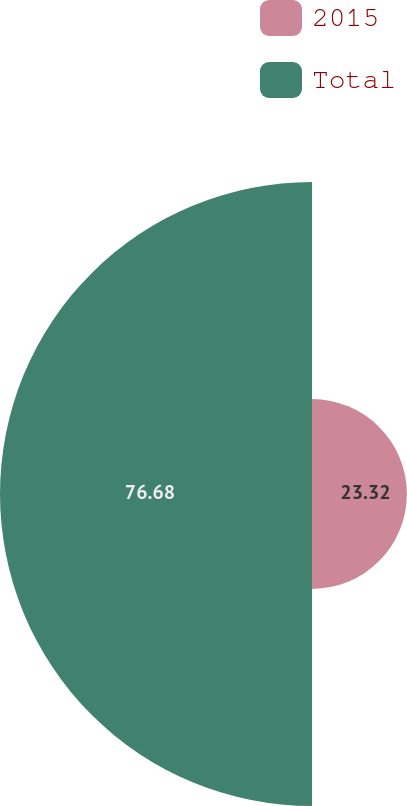Convert chart. <chart><loc_0><loc_0><loc_500><loc_500><pie_chart><fcel>2015<fcel>Total<nl><fcel>23.32%<fcel>76.68%<nl></chart> 